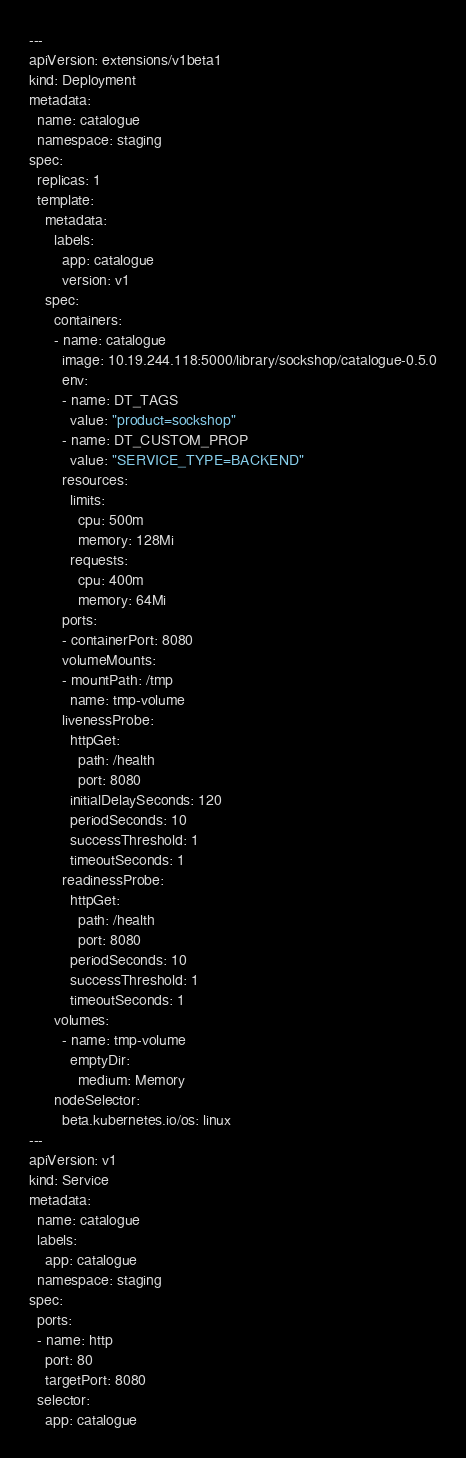Convert code to text. <code><loc_0><loc_0><loc_500><loc_500><_YAML_>---
apiVersion: extensions/v1beta1
kind: Deployment
metadata:
  name: catalogue
  namespace: staging
spec:
  replicas: 1
  template:
    metadata:
      labels:
        app: catalogue
        version: v1
    spec:
      containers:
      - name: catalogue
        image: 10.19.244.118:5000/library/sockshop/catalogue-0.5.0
        env: 
        - name: DT_TAGS
          value: "product=sockshop"
        - name: DT_CUSTOM_PROP
          value: "SERVICE_TYPE=BACKEND"
        resources:
          limits:
            cpu: 500m
            memory: 128Mi
          requests:
            cpu: 400m
            memory: 64Mi
        ports:
        - containerPort: 8080
        volumeMounts:
        - mountPath: /tmp
          name: tmp-volume
        livenessProbe:
          httpGet:
            path: /health
            port: 8080
          initialDelaySeconds: 120
          periodSeconds: 10
          successThreshold: 1
          timeoutSeconds: 1
        readinessProbe:
          httpGet:
            path: /health
            port: 8080
          periodSeconds: 10
          successThreshold: 1
          timeoutSeconds: 1
      volumes:
        - name: tmp-volume
          emptyDir:
            medium: Memory
      nodeSelector:
        beta.kubernetes.io/os: linux
---
apiVersion: v1
kind: Service
metadata:
  name: catalogue
  labels:
    app: catalogue
  namespace: staging
spec:
  ports:
  - name: http
    port: 80
    targetPort: 8080
  selector:
    app: catalogue
</code> 